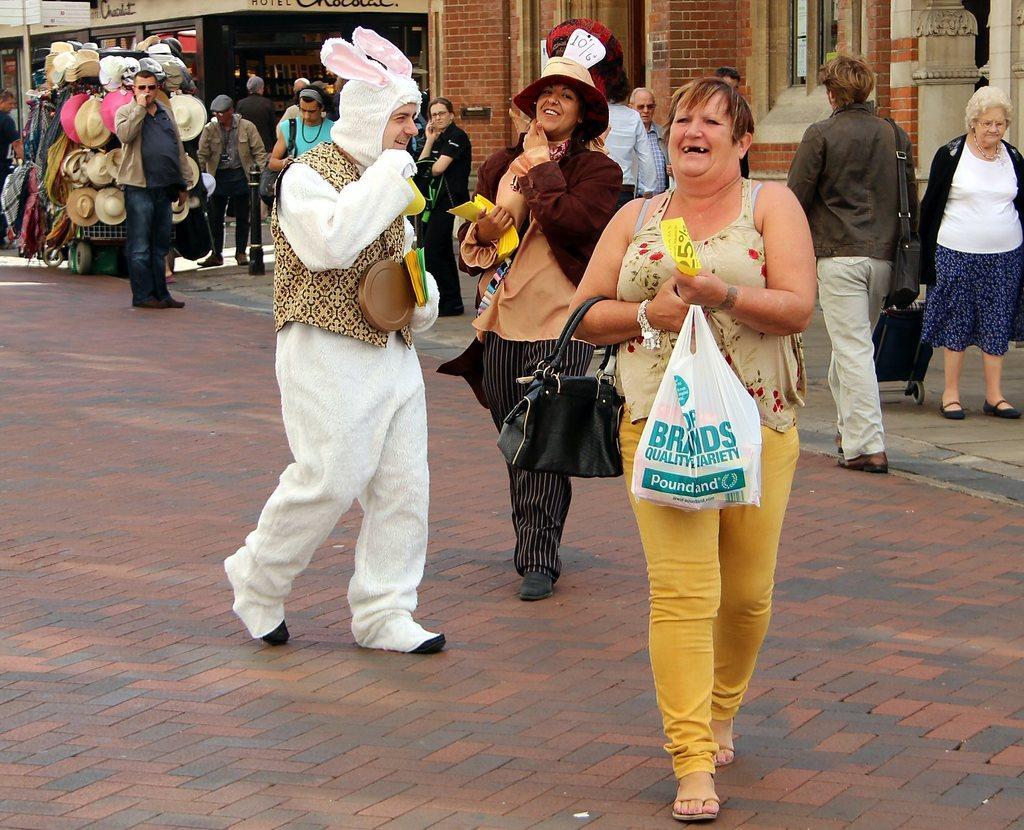Could you give a brief overview of what you see in this image? In this picture there are group of people walking. At the back there are hats and dresses on the vehicle and there are buildings and there is text on the wall. At the bottom there is a road. In the foreground there are three persons walking and smiling. 